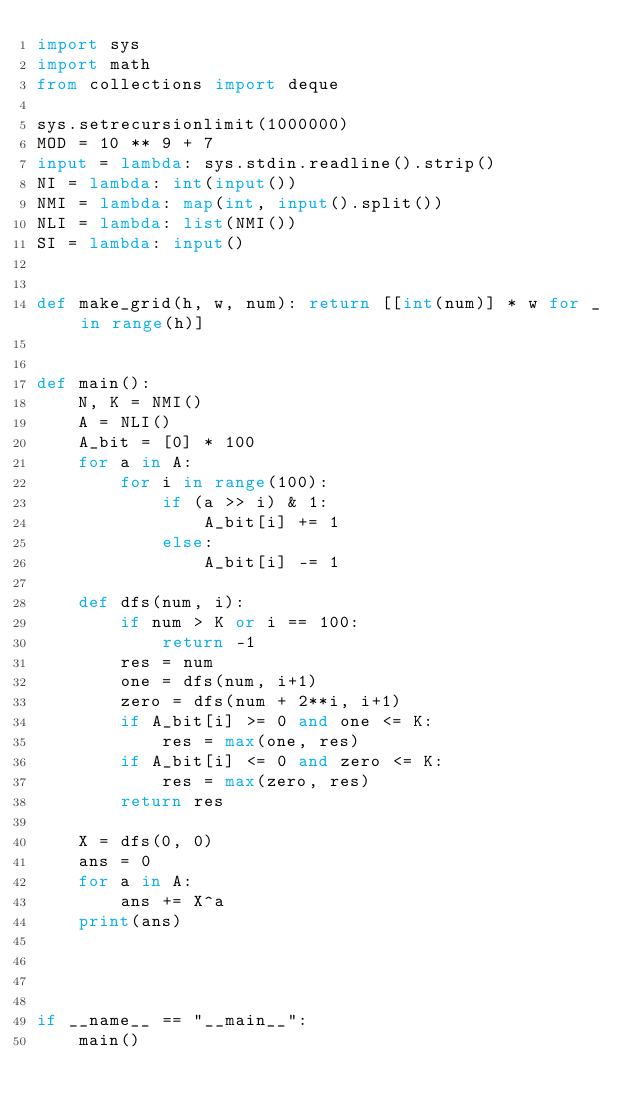<code> <loc_0><loc_0><loc_500><loc_500><_Python_>import sys
import math
from collections import deque

sys.setrecursionlimit(1000000)
MOD = 10 ** 9 + 7
input = lambda: sys.stdin.readline().strip()
NI = lambda: int(input())
NMI = lambda: map(int, input().split())
NLI = lambda: list(NMI())
SI = lambda: input()


def make_grid(h, w, num): return [[int(num)] * w for _ in range(h)]


def main():
    N, K = NMI()
    A = NLI()
    A_bit = [0] * 100
    for a in A:
        for i in range(100):
            if (a >> i) & 1:
                A_bit[i] += 1
            else:
                A_bit[i] -= 1

    def dfs(num, i):
        if num > K or i == 100:
            return -1
        res = num
        one = dfs(num, i+1)
        zero = dfs(num + 2**i, i+1)
        if A_bit[i] >= 0 and one <= K:
            res = max(one, res)
        if A_bit[i] <= 0 and zero <= K:
            res = max(zero, res)
        return res

    X = dfs(0, 0)
    ans = 0
    for a in A:
        ans += X^a
    print(ans)




if __name__ == "__main__":
    main()</code> 